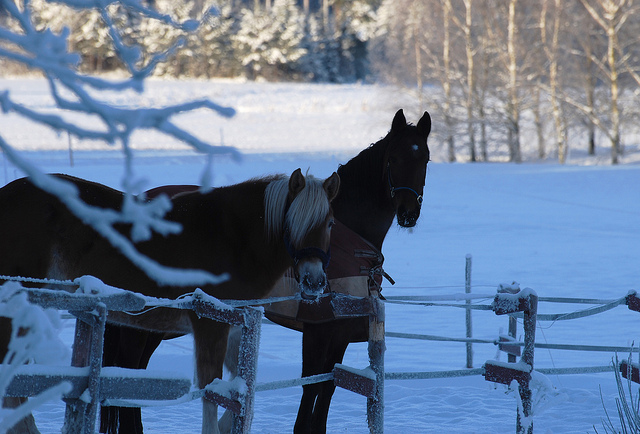How many horses can you see? 2 